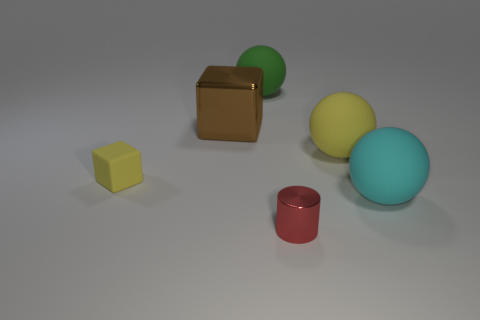Add 1 small cylinders. How many objects exist? 7 Subtract all blocks. How many objects are left? 4 Subtract all small yellow metal cubes. Subtract all large yellow rubber spheres. How many objects are left? 5 Add 1 large metal objects. How many large metal objects are left? 2 Add 1 large cyan objects. How many large cyan objects exist? 2 Subtract 0 purple blocks. How many objects are left? 6 